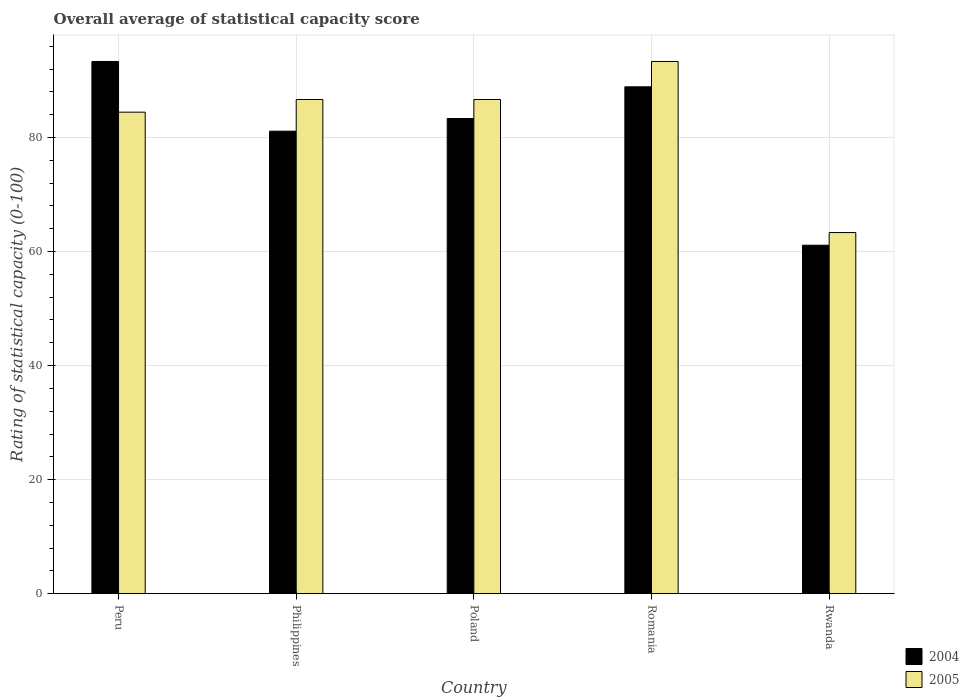How many different coloured bars are there?
Your response must be concise. 2. Are the number of bars per tick equal to the number of legend labels?
Provide a succinct answer. Yes. How many bars are there on the 5th tick from the right?
Offer a very short reply. 2. What is the label of the 4th group of bars from the left?
Keep it short and to the point. Romania. In how many cases, is the number of bars for a given country not equal to the number of legend labels?
Offer a very short reply. 0. What is the rating of statistical capacity in 2004 in Poland?
Your response must be concise. 83.33. Across all countries, what is the maximum rating of statistical capacity in 2004?
Ensure brevity in your answer.  93.33. Across all countries, what is the minimum rating of statistical capacity in 2005?
Provide a short and direct response. 63.33. In which country was the rating of statistical capacity in 2004 minimum?
Keep it short and to the point. Rwanda. What is the total rating of statistical capacity in 2004 in the graph?
Offer a very short reply. 407.78. What is the difference between the rating of statistical capacity in 2005 in Poland and that in Rwanda?
Make the answer very short. 23.33. What is the difference between the rating of statistical capacity in 2004 in Rwanda and the rating of statistical capacity in 2005 in Romania?
Offer a very short reply. -32.22. What is the average rating of statistical capacity in 2005 per country?
Your response must be concise. 82.89. What is the difference between the rating of statistical capacity of/in 2005 and rating of statistical capacity of/in 2004 in Poland?
Keep it short and to the point. 3.33. In how many countries, is the rating of statistical capacity in 2004 greater than 8?
Your answer should be very brief. 5. What is the ratio of the rating of statistical capacity in 2004 in Peru to that in Rwanda?
Your answer should be compact. 1.53. Is the rating of statistical capacity in 2004 in Peru less than that in Poland?
Provide a short and direct response. No. Is the difference between the rating of statistical capacity in 2005 in Philippines and Poland greater than the difference between the rating of statistical capacity in 2004 in Philippines and Poland?
Ensure brevity in your answer.  Yes. What is the difference between the highest and the second highest rating of statistical capacity in 2004?
Your answer should be compact. 5.56. What is the difference between the highest and the lowest rating of statistical capacity in 2004?
Offer a terse response. 32.22. In how many countries, is the rating of statistical capacity in 2005 greater than the average rating of statistical capacity in 2005 taken over all countries?
Your answer should be compact. 4. Is the sum of the rating of statistical capacity in 2004 in Peru and Philippines greater than the maximum rating of statistical capacity in 2005 across all countries?
Your answer should be very brief. Yes. Are all the bars in the graph horizontal?
Keep it short and to the point. No. How many countries are there in the graph?
Provide a short and direct response. 5. What is the difference between two consecutive major ticks on the Y-axis?
Your response must be concise. 20. Are the values on the major ticks of Y-axis written in scientific E-notation?
Keep it short and to the point. No. Does the graph contain any zero values?
Provide a succinct answer. No. Does the graph contain grids?
Ensure brevity in your answer.  Yes. Where does the legend appear in the graph?
Give a very brief answer. Bottom right. How many legend labels are there?
Offer a very short reply. 2. How are the legend labels stacked?
Offer a very short reply. Vertical. What is the title of the graph?
Offer a very short reply. Overall average of statistical capacity score. Does "1979" appear as one of the legend labels in the graph?
Your answer should be compact. No. What is the label or title of the X-axis?
Your answer should be very brief. Country. What is the label or title of the Y-axis?
Your answer should be compact. Rating of statistical capacity (0-100). What is the Rating of statistical capacity (0-100) of 2004 in Peru?
Provide a succinct answer. 93.33. What is the Rating of statistical capacity (0-100) of 2005 in Peru?
Provide a succinct answer. 84.44. What is the Rating of statistical capacity (0-100) in 2004 in Philippines?
Make the answer very short. 81.11. What is the Rating of statistical capacity (0-100) of 2005 in Philippines?
Give a very brief answer. 86.67. What is the Rating of statistical capacity (0-100) in 2004 in Poland?
Provide a short and direct response. 83.33. What is the Rating of statistical capacity (0-100) of 2005 in Poland?
Your response must be concise. 86.67. What is the Rating of statistical capacity (0-100) of 2004 in Romania?
Your response must be concise. 88.89. What is the Rating of statistical capacity (0-100) of 2005 in Romania?
Your answer should be compact. 93.33. What is the Rating of statistical capacity (0-100) of 2004 in Rwanda?
Make the answer very short. 61.11. What is the Rating of statistical capacity (0-100) of 2005 in Rwanda?
Provide a short and direct response. 63.33. Across all countries, what is the maximum Rating of statistical capacity (0-100) of 2004?
Provide a short and direct response. 93.33. Across all countries, what is the maximum Rating of statistical capacity (0-100) of 2005?
Your response must be concise. 93.33. Across all countries, what is the minimum Rating of statistical capacity (0-100) in 2004?
Your answer should be compact. 61.11. Across all countries, what is the minimum Rating of statistical capacity (0-100) of 2005?
Provide a succinct answer. 63.33. What is the total Rating of statistical capacity (0-100) in 2004 in the graph?
Provide a succinct answer. 407.78. What is the total Rating of statistical capacity (0-100) of 2005 in the graph?
Keep it short and to the point. 414.44. What is the difference between the Rating of statistical capacity (0-100) of 2004 in Peru and that in Philippines?
Make the answer very short. 12.22. What is the difference between the Rating of statistical capacity (0-100) in 2005 in Peru and that in Philippines?
Give a very brief answer. -2.22. What is the difference between the Rating of statistical capacity (0-100) of 2005 in Peru and that in Poland?
Make the answer very short. -2.22. What is the difference between the Rating of statistical capacity (0-100) in 2004 in Peru and that in Romania?
Provide a succinct answer. 4.44. What is the difference between the Rating of statistical capacity (0-100) in 2005 in Peru and that in Romania?
Provide a succinct answer. -8.89. What is the difference between the Rating of statistical capacity (0-100) in 2004 in Peru and that in Rwanda?
Offer a terse response. 32.22. What is the difference between the Rating of statistical capacity (0-100) of 2005 in Peru and that in Rwanda?
Your response must be concise. 21.11. What is the difference between the Rating of statistical capacity (0-100) of 2004 in Philippines and that in Poland?
Offer a very short reply. -2.22. What is the difference between the Rating of statistical capacity (0-100) of 2005 in Philippines and that in Poland?
Offer a very short reply. 0. What is the difference between the Rating of statistical capacity (0-100) in 2004 in Philippines and that in Romania?
Keep it short and to the point. -7.78. What is the difference between the Rating of statistical capacity (0-100) of 2005 in Philippines and that in Romania?
Give a very brief answer. -6.67. What is the difference between the Rating of statistical capacity (0-100) in 2005 in Philippines and that in Rwanda?
Make the answer very short. 23.33. What is the difference between the Rating of statistical capacity (0-100) in 2004 in Poland and that in Romania?
Your answer should be very brief. -5.56. What is the difference between the Rating of statistical capacity (0-100) in 2005 in Poland and that in Romania?
Offer a terse response. -6.67. What is the difference between the Rating of statistical capacity (0-100) of 2004 in Poland and that in Rwanda?
Keep it short and to the point. 22.22. What is the difference between the Rating of statistical capacity (0-100) in 2005 in Poland and that in Rwanda?
Keep it short and to the point. 23.33. What is the difference between the Rating of statistical capacity (0-100) of 2004 in Romania and that in Rwanda?
Make the answer very short. 27.78. What is the difference between the Rating of statistical capacity (0-100) in 2005 in Romania and that in Rwanda?
Provide a succinct answer. 30. What is the difference between the Rating of statistical capacity (0-100) of 2004 in Peru and the Rating of statistical capacity (0-100) of 2005 in Poland?
Offer a very short reply. 6.67. What is the difference between the Rating of statistical capacity (0-100) in 2004 in Peru and the Rating of statistical capacity (0-100) in 2005 in Rwanda?
Keep it short and to the point. 30. What is the difference between the Rating of statistical capacity (0-100) in 2004 in Philippines and the Rating of statistical capacity (0-100) in 2005 in Poland?
Give a very brief answer. -5.56. What is the difference between the Rating of statistical capacity (0-100) of 2004 in Philippines and the Rating of statistical capacity (0-100) of 2005 in Romania?
Offer a very short reply. -12.22. What is the difference between the Rating of statistical capacity (0-100) of 2004 in Philippines and the Rating of statistical capacity (0-100) of 2005 in Rwanda?
Offer a terse response. 17.78. What is the difference between the Rating of statistical capacity (0-100) of 2004 in Romania and the Rating of statistical capacity (0-100) of 2005 in Rwanda?
Offer a very short reply. 25.56. What is the average Rating of statistical capacity (0-100) of 2004 per country?
Give a very brief answer. 81.56. What is the average Rating of statistical capacity (0-100) in 2005 per country?
Your answer should be compact. 82.89. What is the difference between the Rating of statistical capacity (0-100) of 2004 and Rating of statistical capacity (0-100) of 2005 in Peru?
Your answer should be compact. 8.89. What is the difference between the Rating of statistical capacity (0-100) in 2004 and Rating of statistical capacity (0-100) in 2005 in Philippines?
Provide a succinct answer. -5.56. What is the difference between the Rating of statistical capacity (0-100) in 2004 and Rating of statistical capacity (0-100) in 2005 in Poland?
Make the answer very short. -3.33. What is the difference between the Rating of statistical capacity (0-100) in 2004 and Rating of statistical capacity (0-100) in 2005 in Romania?
Give a very brief answer. -4.44. What is the difference between the Rating of statistical capacity (0-100) in 2004 and Rating of statistical capacity (0-100) in 2005 in Rwanda?
Give a very brief answer. -2.22. What is the ratio of the Rating of statistical capacity (0-100) in 2004 in Peru to that in Philippines?
Ensure brevity in your answer.  1.15. What is the ratio of the Rating of statistical capacity (0-100) of 2005 in Peru to that in Philippines?
Your answer should be very brief. 0.97. What is the ratio of the Rating of statistical capacity (0-100) of 2004 in Peru to that in Poland?
Your response must be concise. 1.12. What is the ratio of the Rating of statistical capacity (0-100) in 2005 in Peru to that in Poland?
Provide a succinct answer. 0.97. What is the ratio of the Rating of statistical capacity (0-100) of 2005 in Peru to that in Romania?
Make the answer very short. 0.9. What is the ratio of the Rating of statistical capacity (0-100) in 2004 in Peru to that in Rwanda?
Your answer should be compact. 1.53. What is the ratio of the Rating of statistical capacity (0-100) in 2005 in Peru to that in Rwanda?
Give a very brief answer. 1.33. What is the ratio of the Rating of statistical capacity (0-100) of 2004 in Philippines to that in Poland?
Offer a terse response. 0.97. What is the ratio of the Rating of statistical capacity (0-100) in 2004 in Philippines to that in Romania?
Provide a succinct answer. 0.91. What is the ratio of the Rating of statistical capacity (0-100) of 2004 in Philippines to that in Rwanda?
Keep it short and to the point. 1.33. What is the ratio of the Rating of statistical capacity (0-100) of 2005 in Philippines to that in Rwanda?
Give a very brief answer. 1.37. What is the ratio of the Rating of statistical capacity (0-100) in 2004 in Poland to that in Romania?
Give a very brief answer. 0.94. What is the ratio of the Rating of statistical capacity (0-100) of 2004 in Poland to that in Rwanda?
Keep it short and to the point. 1.36. What is the ratio of the Rating of statistical capacity (0-100) of 2005 in Poland to that in Rwanda?
Keep it short and to the point. 1.37. What is the ratio of the Rating of statistical capacity (0-100) in 2004 in Romania to that in Rwanda?
Your response must be concise. 1.45. What is the ratio of the Rating of statistical capacity (0-100) of 2005 in Romania to that in Rwanda?
Offer a very short reply. 1.47. What is the difference between the highest and the second highest Rating of statistical capacity (0-100) in 2004?
Your answer should be very brief. 4.44. What is the difference between the highest and the lowest Rating of statistical capacity (0-100) in 2004?
Offer a very short reply. 32.22. 